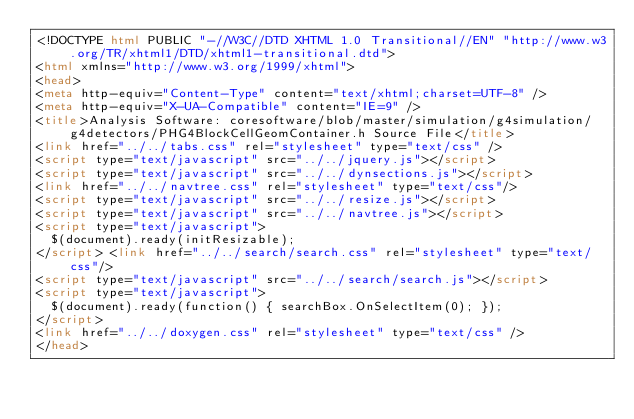Convert code to text. <code><loc_0><loc_0><loc_500><loc_500><_HTML_><!DOCTYPE html PUBLIC "-//W3C//DTD XHTML 1.0 Transitional//EN" "http://www.w3.org/TR/xhtml1/DTD/xhtml1-transitional.dtd">
<html xmlns="http://www.w3.org/1999/xhtml">
<head>
<meta http-equiv="Content-Type" content="text/xhtml;charset=UTF-8" />
<meta http-equiv="X-UA-Compatible" content="IE=9" />
<title>Analysis Software: coresoftware/blob/master/simulation/g4simulation/g4detectors/PHG4BlockCellGeomContainer.h Source File</title>
<link href="../../tabs.css" rel="stylesheet" type="text/css" />
<script type="text/javascript" src="../../jquery.js"></script>
<script type="text/javascript" src="../../dynsections.js"></script>
<link href="../../navtree.css" rel="stylesheet" type="text/css"/>
<script type="text/javascript" src="../../resize.js"></script>
<script type="text/javascript" src="../../navtree.js"></script>
<script type="text/javascript">
  $(document).ready(initResizable);
</script> <link href="../../search/search.css" rel="stylesheet" type="text/css"/>
<script type="text/javascript" src="../../search/search.js"></script>
<script type="text/javascript">
  $(document).ready(function() { searchBox.OnSelectItem(0); });
</script> 
<link href="../../doxygen.css" rel="stylesheet" type="text/css" />
</head></code> 